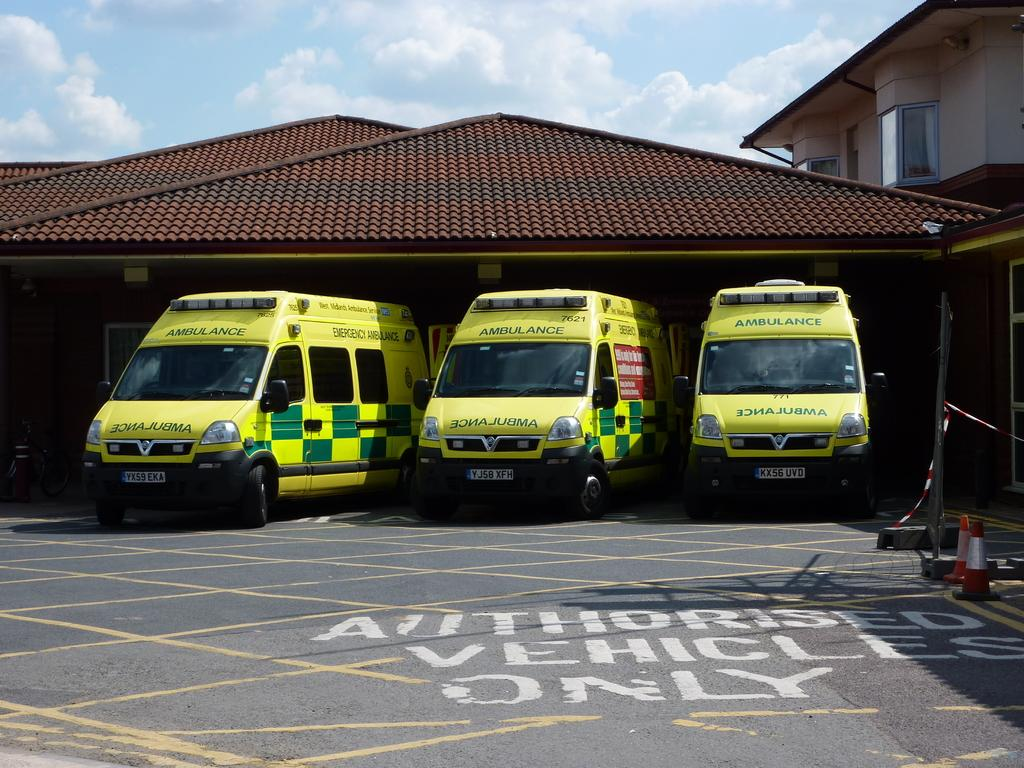What type of structure is present in the image? There is a building in the image. What feature can be seen on the building? The building has windows. What objects are present near the building? There are traffic cones and a pole in the image. What type of objects are present in the image that are used for transportation? There are vehicles in the image. What colors can be seen on some of the vehicles in the image? Some of the vehicles are yellow and green. How many pickles are on top of the building in the image? There are no pickles present in the image; they are not related to the objects or features shown. 